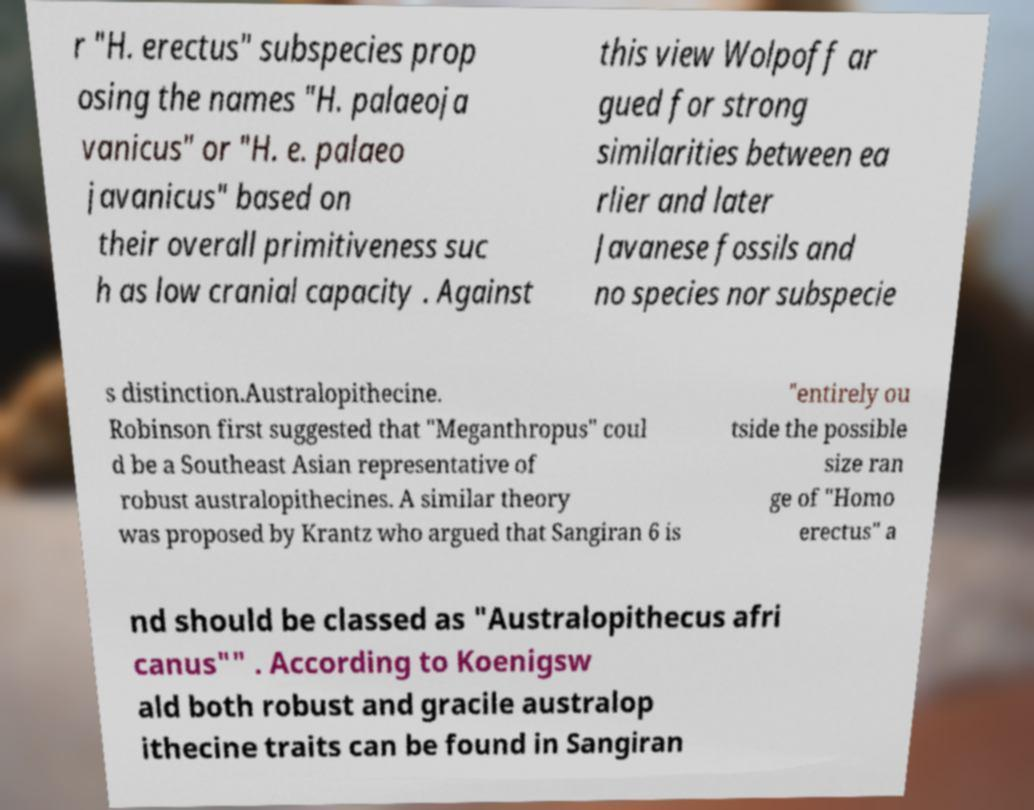For documentation purposes, I need the text within this image transcribed. Could you provide that? r "H. erectus" subspecies prop osing the names "H. palaeoja vanicus" or "H. e. palaeo javanicus" based on their overall primitiveness suc h as low cranial capacity . Against this view Wolpoff ar gued for strong similarities between ea rlier and later Javanese fossils and no species nor subspecie s distinction.Australopithecine. Robinson first suggested that "Meganthropus" coul d be a Southeast Asian representative of robust australopithecines. A similar theory was proposed by Krantz who argued that Sangiran 6 is "entirely ou tside the possible size ran ge of "Homo erectus" a nd should be classed as "Australopithecus afri canus"" . According to Koenigsw ald both robust and gracile australop ithecine traits can be found in Sangiran 